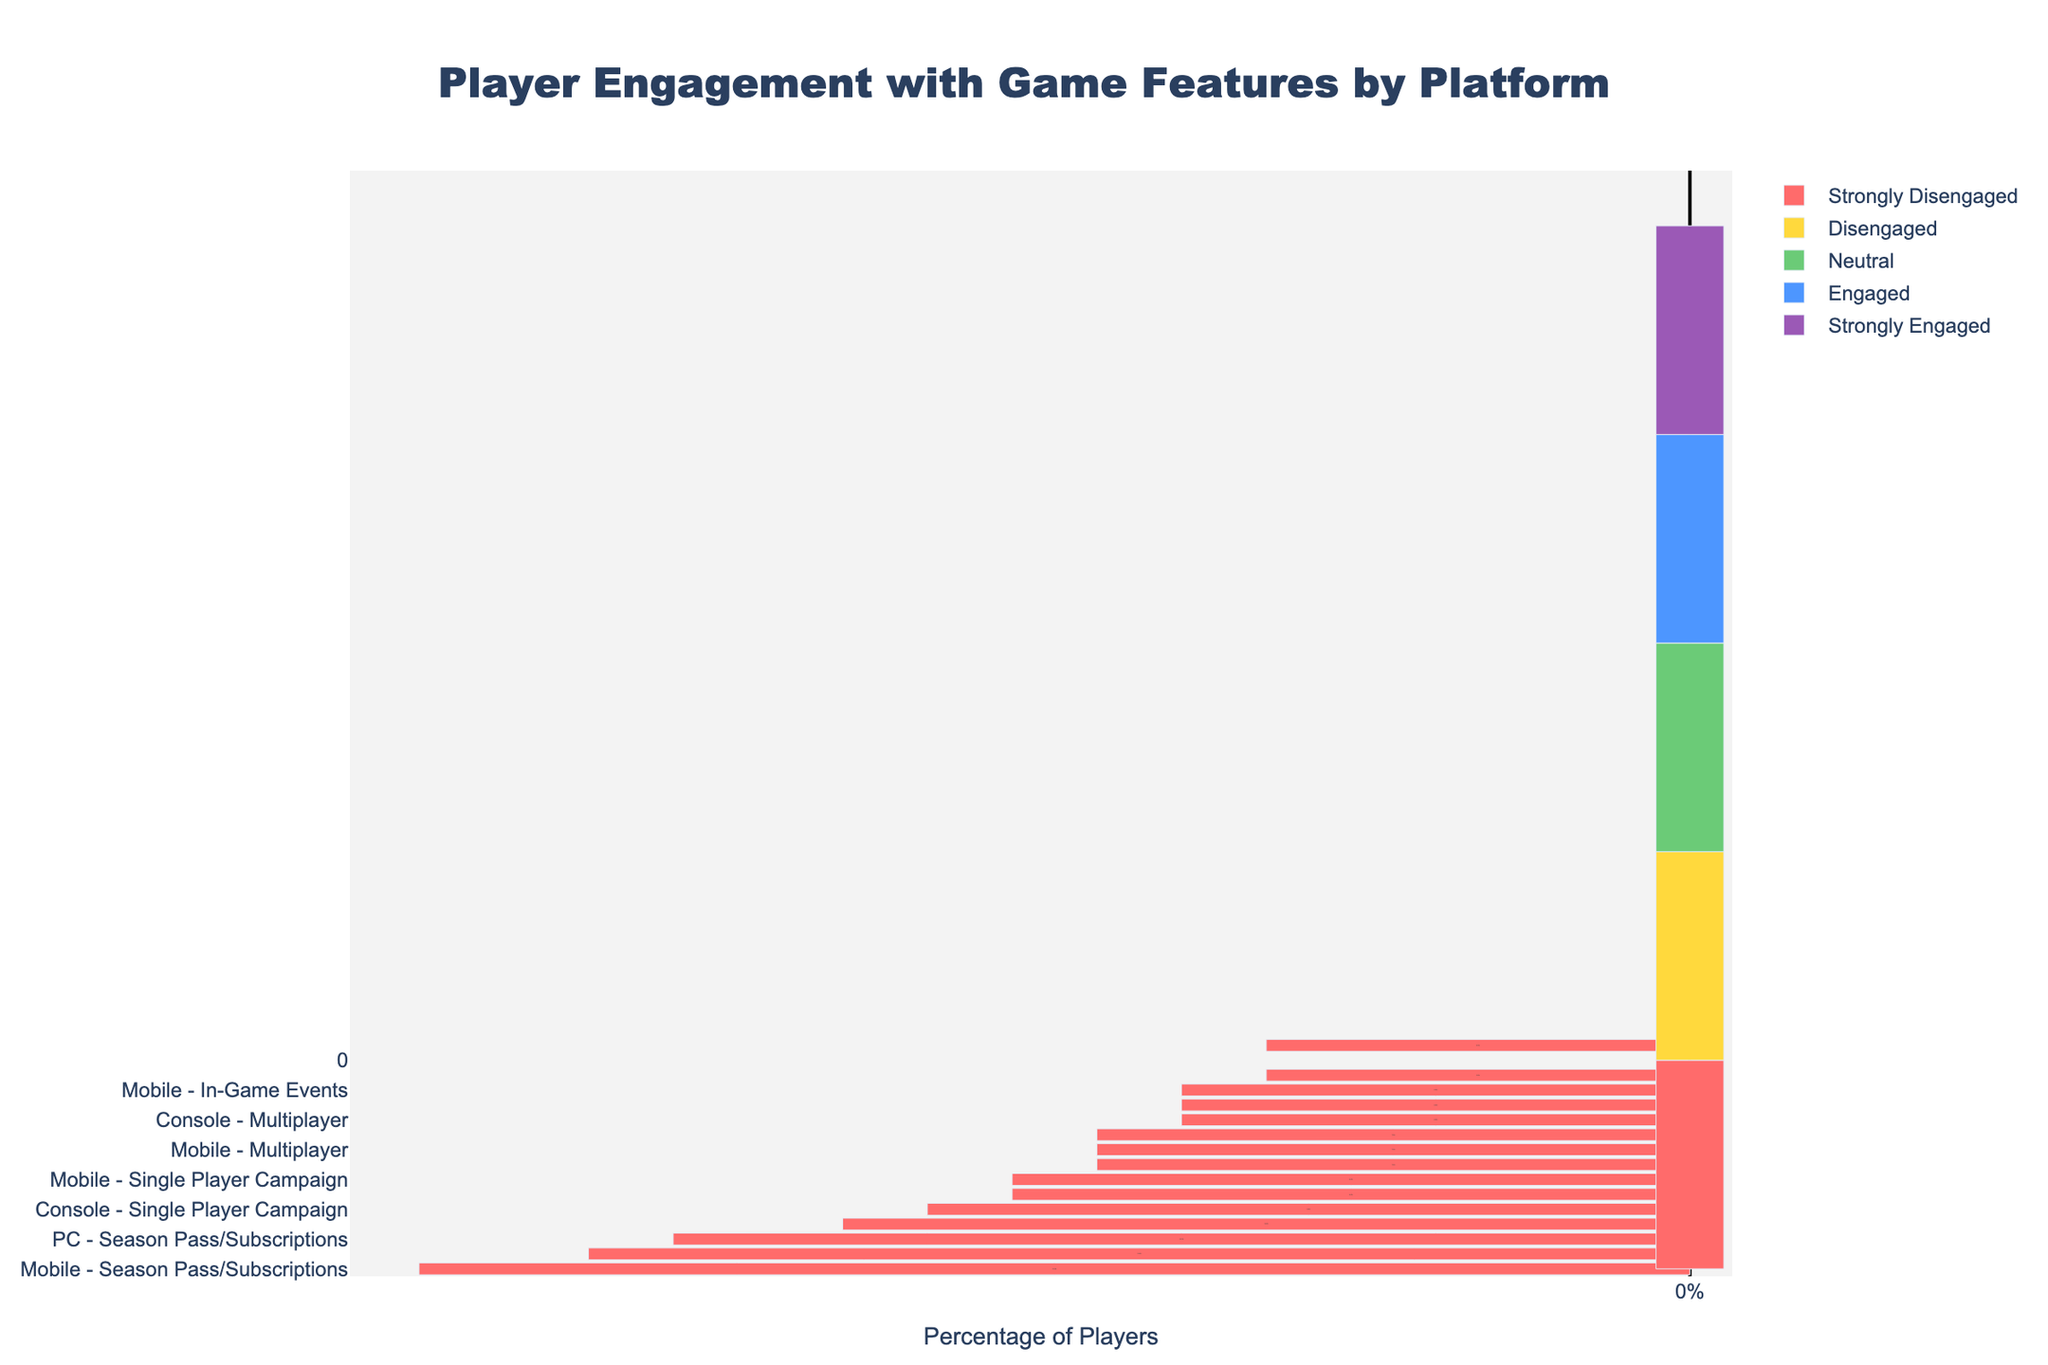What's the most engaged feature on the PC platform? Look at the bar that extends the furthest to the right for the PC platform. Character Customization has the most significant portion in strong engagement.
Answer: Character Customization What platform has the highest disengagement in Season Pass/Subscriptions? Compare the bars on the left side for Season Pass/Subscriptions across all platforms. Mobile has the largest section in strongly disengaged and disengaged.
Answer: Mobile Which feature has the highest percentage of neutral engagement on consoles? Locate the neutral engagement section (central part) for each feature on the Console platform. Single Player Campaign has the most extensive section in neutral engagement.
Answer: Single Player Campaign What's the average percentage of engagement levels (Engaged and Strongly Engaged) for Multiplayer across all platforms? First, calculate the engaged percentages for Multiplayer on each platform (PC: 40+30=70%, Console: 38+29=67%, Mobile: 34+29=63%), then average them: (70+67+63)/3.
Answer: 66.7% Compare the difference in strongly engaged players for Character Customization between PC and Console. For Character Customization, PC has 42% strongly engaged players, and Console has 39%. Subtract to find the difference: 42% - 39%.
Answer: 3% Which feature shows the highest discrepancy between strongly disengaged and strongly engaged players on the Mobile platform? Calculate the difference for each feature on Mobile between strongly disengaged and strongly engaged sections. Season Pass/Subscriptions has the highest discrepancy (15% - 11% = 4%).
Answer: Character Customization Which platform has a more balanced engagement distribution for In-Game Events? Look at the distribution of bars (left and right sides) for In-Game Events across platforms. Console looks more balanced with similar proportions across engagement levels.
Answer: Console Is the Single Player Campaign more engaged on the PC or Mobile platform? Compare the right side (engaged and strongly engaged) for Single Player Campaign on PC (30+25=55%) and Mobile (30+22=52%). PC is slightly higher.
Answer: PC Which platform has the highest absolute number of neutral players for Character Customization? Check the central part (neutral engagement) for Character Customization across platforms. PC and Mobile have the same number (10%), the highest proportion of neutral players.
Answer: PC, Mobile 